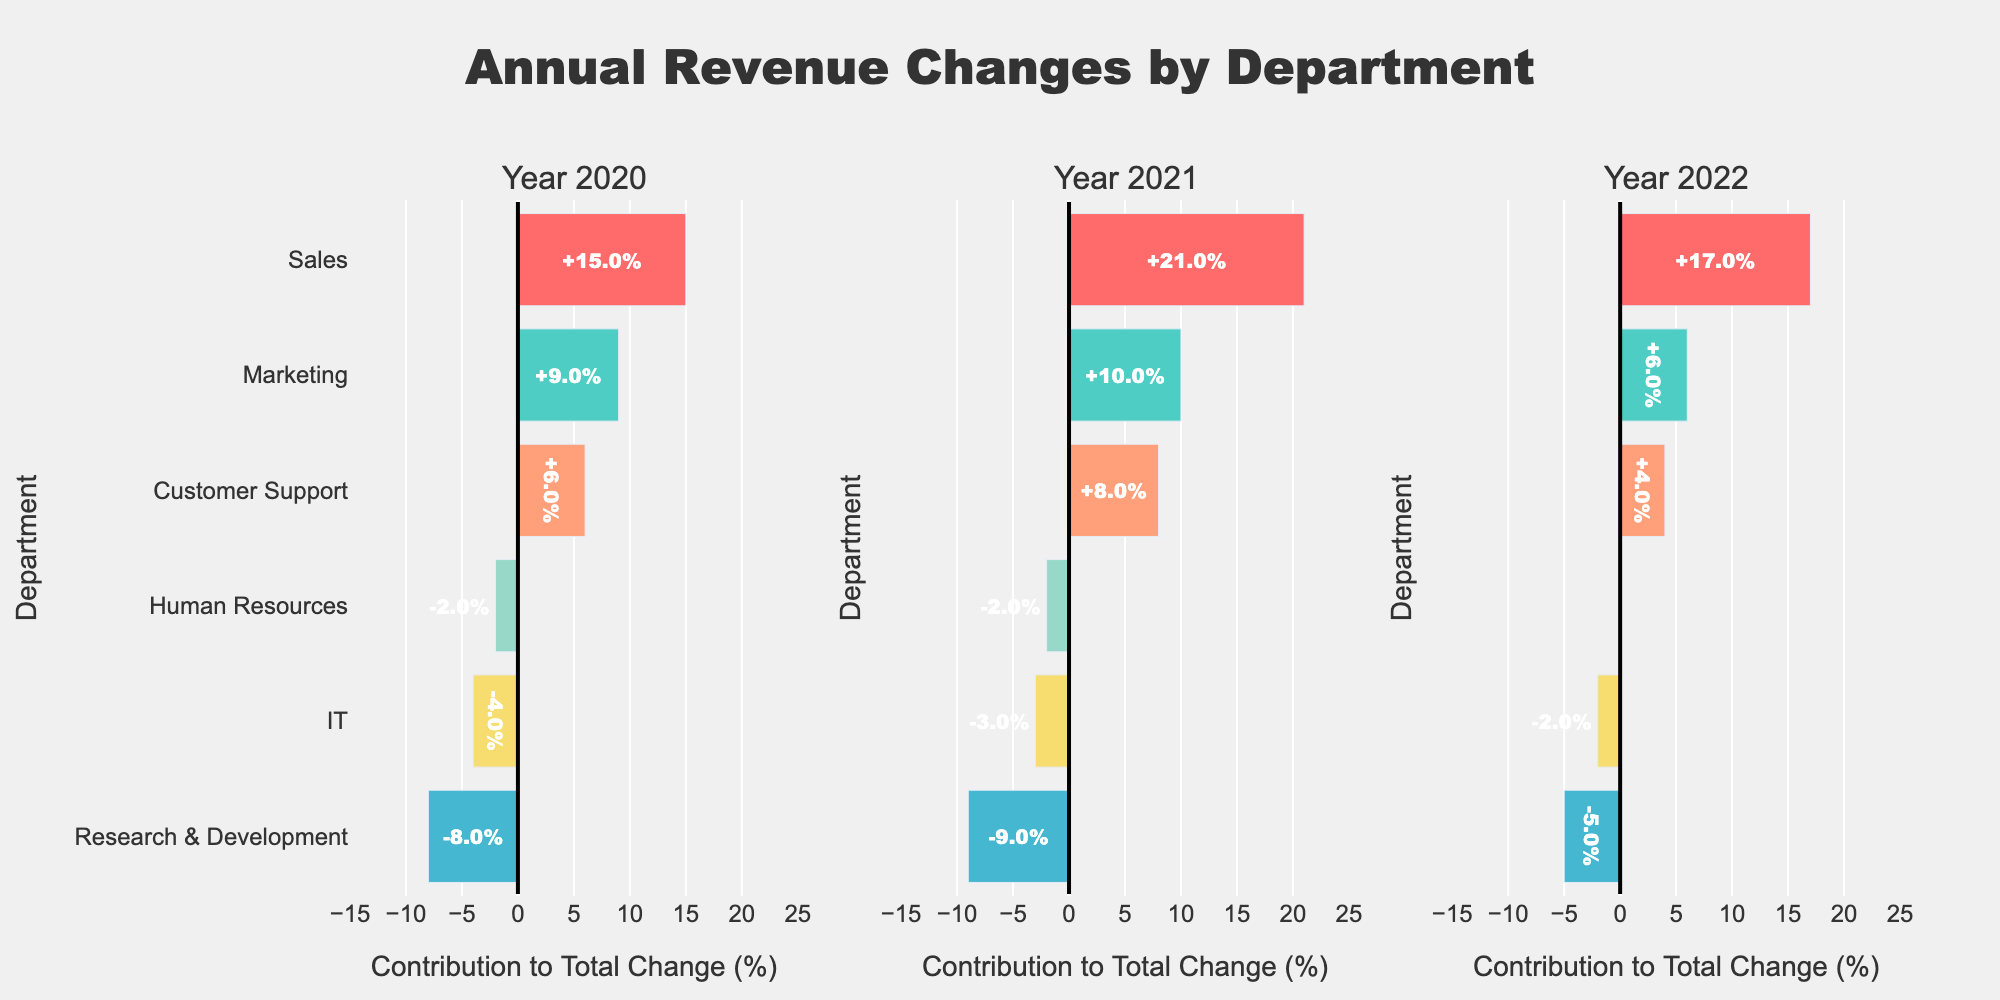Which department had the largest positive contribution to the total revenue change in 2021? Start by looking at the bars for the 2021 column. Identify the department with the longest bar to the right (positive side). The Sales department had the largest positive contribution.
Answer: Sales Which department had consistent negative contributions to the total revenue change from 2020 to 2022? Locate departments with negative values (bars extending to the left) for all three years. Both IT and Research & Development have consistent negative contributions across all years.
Answer: IT and Research & Development What was the total positive contribution to the revenue change in 2022? Sum up the positive contributions in 2022: Sales (17) + Marketing (6) + Customer Support (4). The total is 17 + 6 + 4 = 27.
Answer: 27 How did the contribution of Marketing change from 2020 to 2021? Note the Marketing contributions: in 2020 it was +9 and in 2021 it was +10. Calculate the difference: 10 - 9 = +1.
Answer: Increased by 1 Which departments showed improved contributions from 2021 to 2022? Compare each department's contributions between these two years. Departments with higher values in 2022 compared to 2021 are considered improved. Customer Support and IT showed improved contributions from 2021 to 2022.
Answer: Customer Support and IT In which year did Human Resources show the least negative contribution? Check the bars for Human Resources in each year. In 2022, the contribution is 0, which is the least negative compared to -2 in 2020 and -2 in 2021.
Answer: 2022 What is the overall trend for the Sales department from 2020 to 2022? Track the contributions from Sales for the three years: 15 in 2020, 21 in 2021, and 17 in 2022. Observe the progression: it increased from 2020 to 2021 then slightly decreased in 2022.
Answer: Increased then slightly decreased Which department had the smallest positive contribution to the total revenue change in 2020? Among the departments with positive contributions in 2020, Customer Support has the smallest positive contribution (6).
Answer: Customer Support Calculate the average positive contribution of the Marketing department from 2020 to 2022. Find the contributions of Marketing across all years and average them. Marketing contributions are 9 (2020), 10 (2021), and 6 (2022). Average = (9 + 10 + 6) / 3 = 25 / 3 = 8.33.
Answer: 8.33 Compare the total contributions for Research & Development and IT over three years. Which had a more negative impact? Sum contributions for each department over 3 years: R&D: -8 + (-9) + (-5) = -22, IT: -4 + (-3) + (-2) = -9. Research & Development had a more negative impact.
Answer: Research & Development 